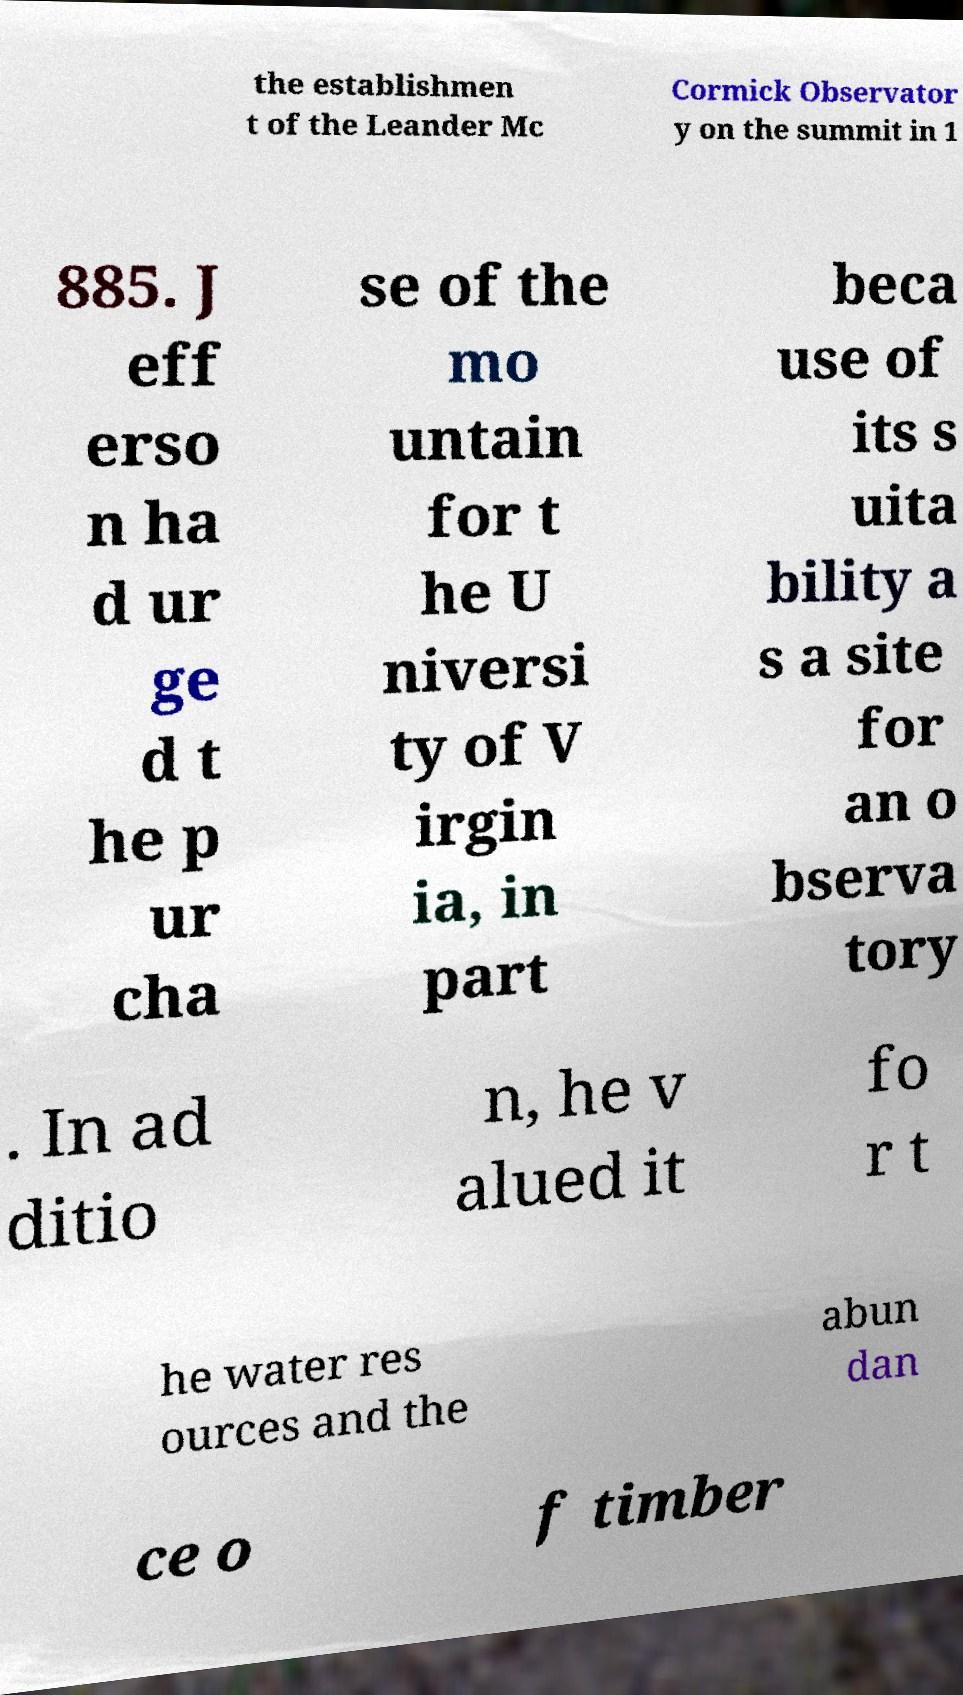There's text embedded in this image that I need extracted. Can you transcribe it verbatim? the establishmen t of the Leander Mc Cormick Observator y on the summit in 1 885. J eff erso n ha d ur ge d t he p ur cha se of the mo untain for t he U niversi ty of V irgin ia, in part beca use of its s uita bility a s a site for an o bserva tory . In ad ditio n, he v alued it fo r t he water res ources and the abun dan ce o f timber 